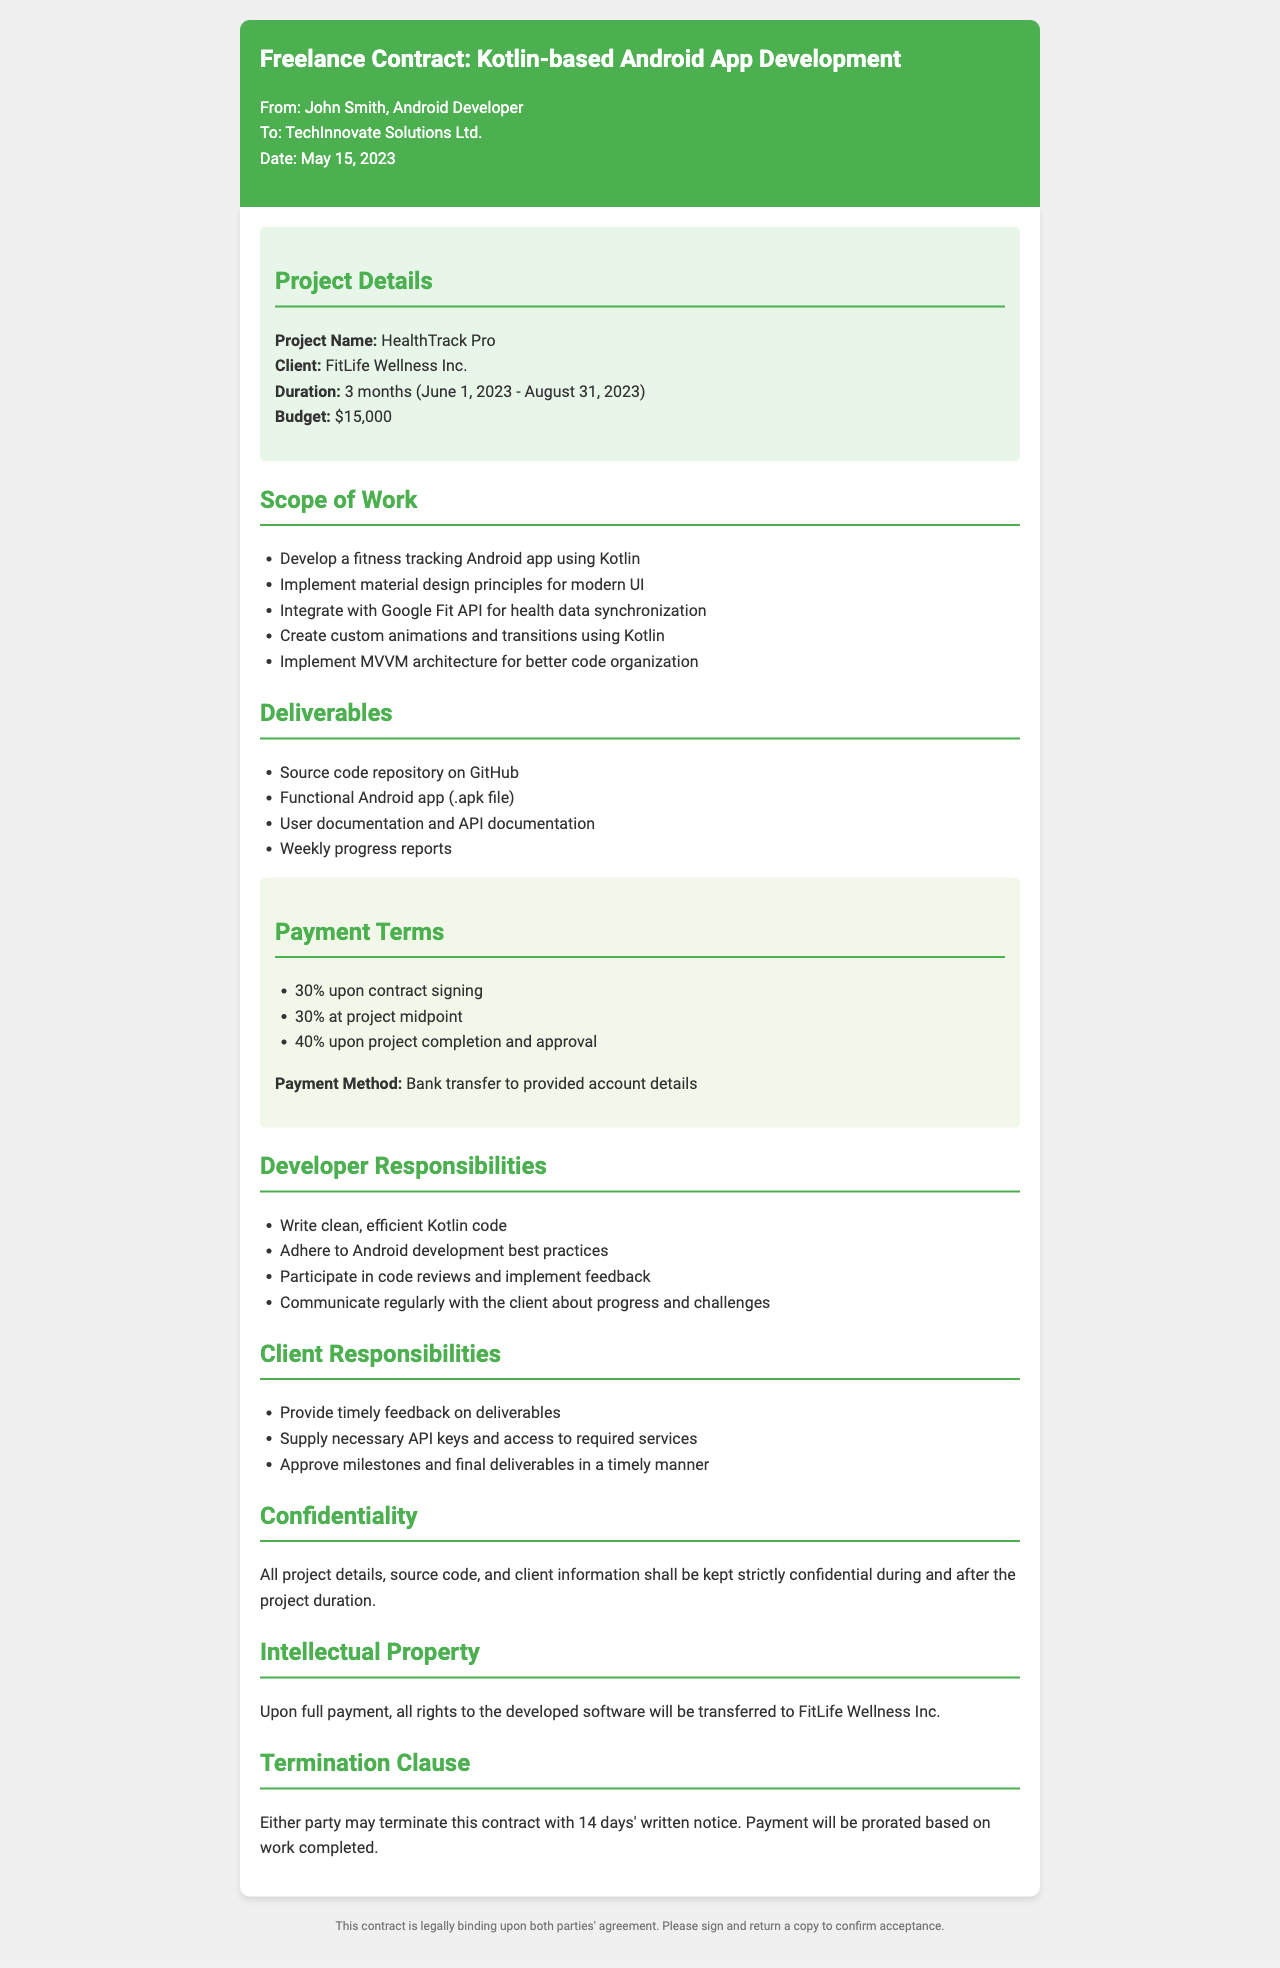What is the project name? The project name is clearly specified in the project details section of the document as "HealthTrack Pro."
Answer: HealthTrack Pro Who is the client? The client’s name is indicated in the project details section, listed as "FitLife Wellness Inc."
Answer: FitLife Wellness Inc What is the budget for the project? The budget is mentioned in the project details section, which states that it is "$15,000."
Answer: $15,000 What is the duration of the project? The duration is specified in the project details section, covering the period from June 1, 2023, to August 31, 2023.
Answer: 3 months What percentage is paid upon contract signing? The payment terms section outlines that "30%" is due upon contract signing.
Answer: 30% Which API will be integrated for health data synchronization? The scope of work specifically mentions "Google Fit API" for synchronization purposes.
Answer: Google Fit API What architecture is to be implemented for code organization? The document refers to the implementation of "MVVM architecture" for the project.
Answer: MVVM architecture What is one of the developer's responsibilities? The developer's responsibilities section lists several tasks, one of which is to "Write clean, efficient Kotlin code."
Answer: Write clean, efficient Kotlin code What happens to intellectual property upon full payment? The intellectual property section indicates that all rights to the software will be "transferred to FitLife Wellness Inc."
Answer: transferred to FitLife Wellness Inc How many days' notice is required for termination? The termination clause states that "14 days' written notice" is required for either party to terminate the contract.
Answer: 14 days 